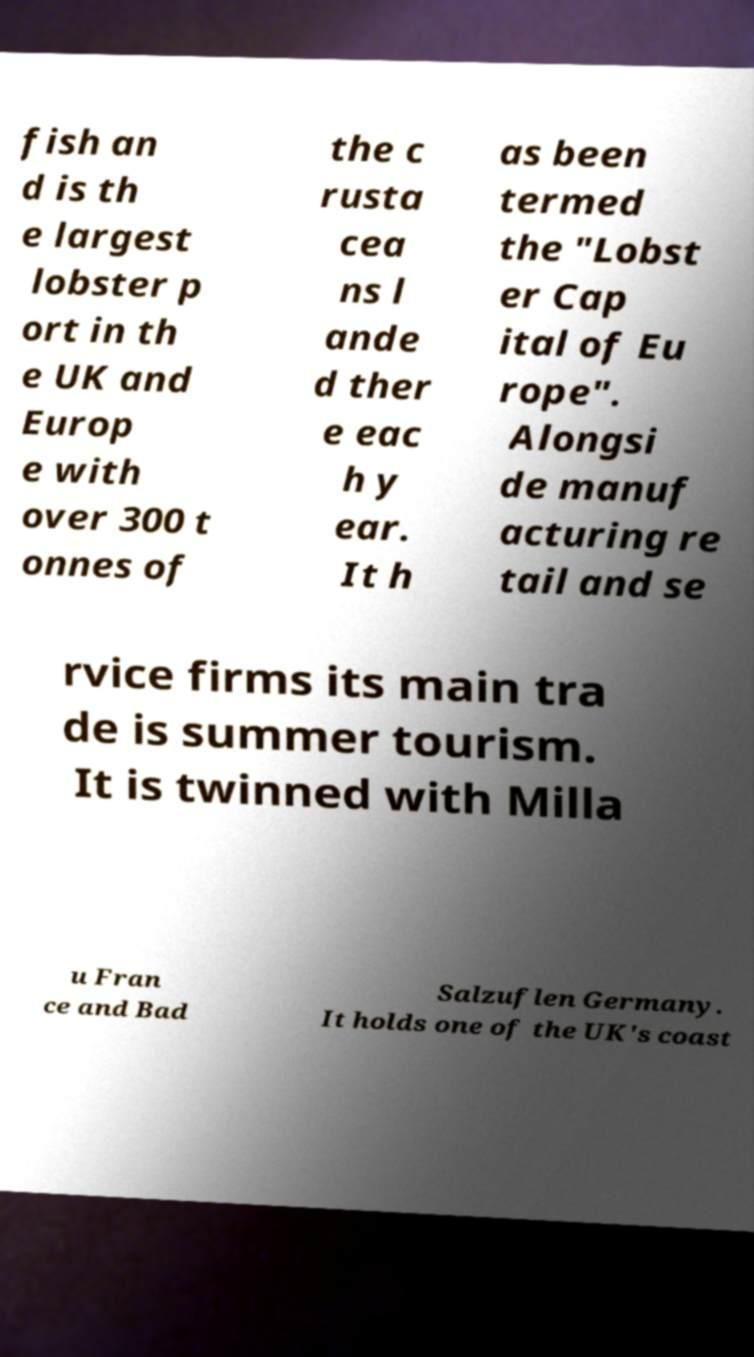Please read and relay the text visible in this image. What does it say? fish an d is th e largest lobster p ort in th e UK and Europ e with over 300 t onnes of the c rusta cea ns l ande d ther e eac h y ear. It h as been termed the "Lobst er Cap ital of Eu rope". Alongsi de manuf acturing re tail and se rvice firms its main tra de is summer tourism. It is twinned with Milla u Fran ce and Bad Salzuflen Germany. It holds one of the UK's coast 